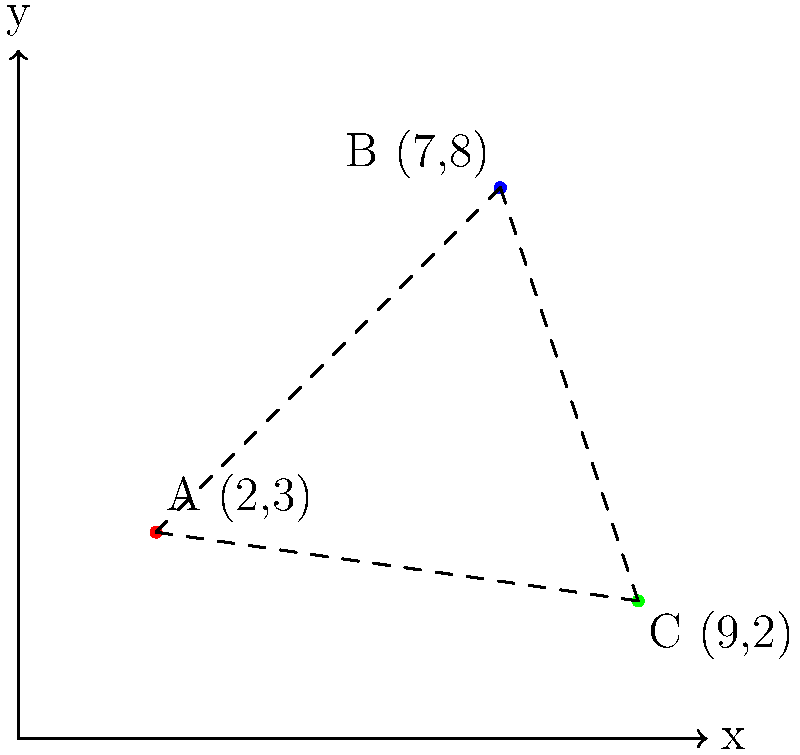In a securities litigation case, three financial institutions are represented on a coordinate plane: Bank A at (2,3), Investment Firm B at (7,8), and Hedge Fund C at (9,2). Calculate the total distance between all three institutions, rounded to two decimal places. To solve this problem, we need to calculate the distances between each pair of points and sum them up. We'll use the distance formula: $d = \sqrt{(x_2-x_1)^2 + (y_2-y_1)^2}$

Step 1: Calculate distance between A and B
$$d_{AB} = \sqrt{(7-2)^2 + (8-3)^2} = \sqrt{5^2 + 5^2} = \sqrt{50} = 5\sqrt{2} \approx 7.07$$

Step 2: Calculate distance between B and C
$$d_{BC} = \sqrt{(9-7)^2 + (2-8)^2} = \sqrt{2^2 + (-6)^2} = \sqrt{4 + 36} = \sqrt{40} = 2\sqrt{10} \approx 6.32$$

Step 3: Calculate distance between C and A
$$d_{CA} = \sqrt{(2-9)^2 + (3-2)^2} = \sqrt{(-7)^2 + 1^2} = \sqrt{49 + 1} = \sqrt{50} = 5\sqrt{2} \approx 7.07$$

Step 4: Sum up all distances
Total distance = $d_{AB} + d_{BC} + d_{CA}$
$\approx 7.07 + 6.32 + 7.07 = 20.46$

Rounding to two decimal places, we get 20.46.
Answer: 20.46 units 